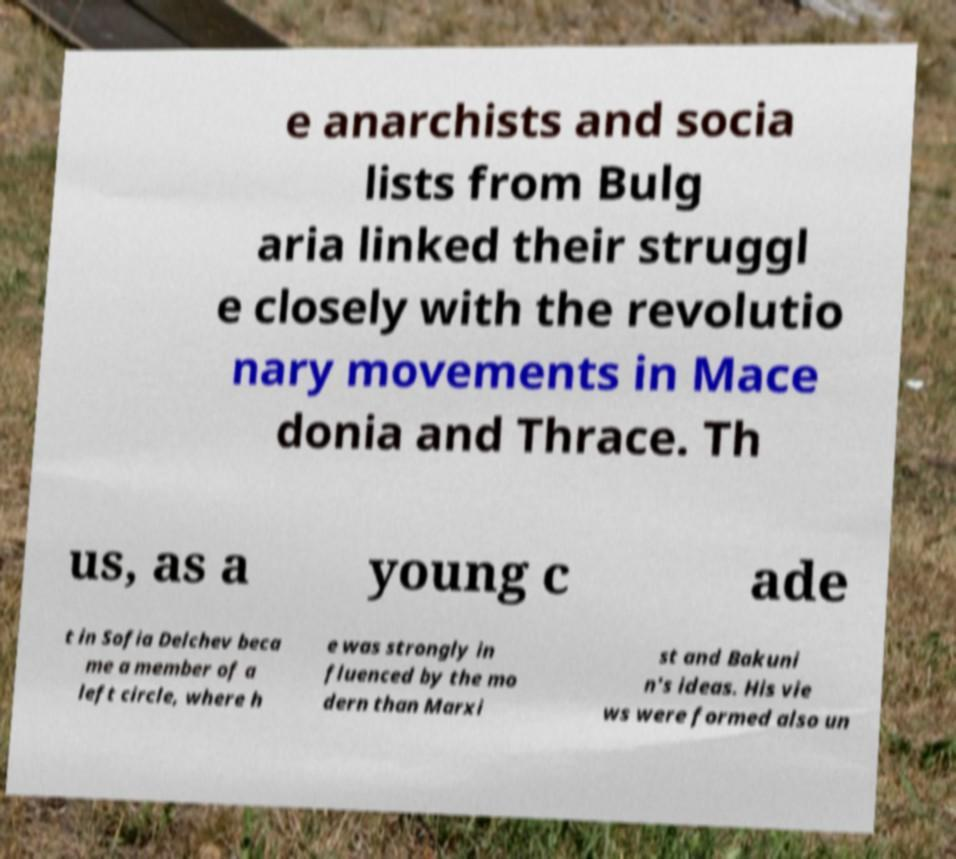Can you accurately transcribe the text from the provided image for me? e anarchists and socia lists from Bulg aria linked their struggl e closely with the revolutio nary movements in Mace donia and Thrace. Th us, as a young c ade t in Sofia Delchev beca me a member of a left circle, where h e was strongly in fluenced by the mo dern than Marxi st and Bakuni n's ideas. His vie ws were formed also un 